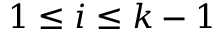Convert formula to latex. <formula><loc_0><loc_0><loc_500><loc_500>1 \leq i \leq k - 1</formula> 